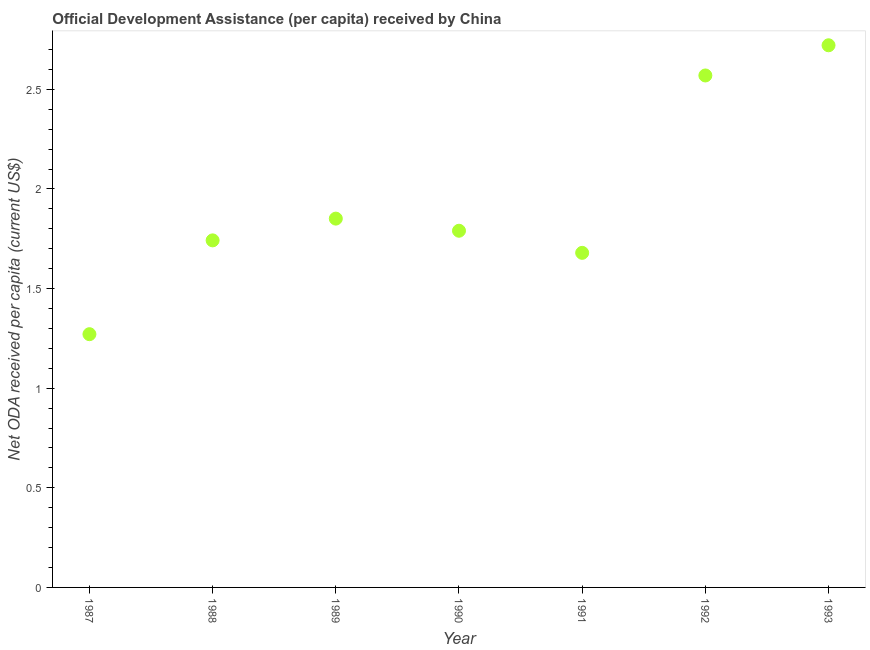What is the net oda received per capita in 1987?
Provide a short and direct response. 1.27. Across all years, what is the maximum net oda received per capita?
Give a very brief answer. 2.72. Across all years, what is the minimum net oda received per capita?
Ensure brevity in your answer.  1.27. In which year was the net oda received per capita minimum?
Ensure brevity in your answer.  1987. What is the sum of the net oda received per capita?
Give a very brief answer. 13.63. What is the difference between the net oda received per capita in 1987 and 1989?
Offer a very short reply. -0.58. What is the average net oda received per capita per year?
Your response must be concise. 1.95. What is the median net oda received per capita?
Offer a terse response. 1.79. In how many years, is the net oda received per capita greater than 1.7 US$?
Offer a very short reply. 5. Do a majority of the years between 1993 and 1988 (inclusive) have net oda received per capita greater than 0.4 US$?
Provide a short and direct response. Yes. What is the ratio of the net oda received per capita in 1989 to that in 1991?
Your answer should be very brief. 1.1. Is the net oda received per capita in 1987 less than that in 1988?
Provide a short and direct response. Yes. What is the difference between the highest and the second highest net oda received per capita?
Give a very brief answer. 0.15. What is the difference between the highest and the lowest net oda received per capita?
Your answer should be very brief. 1.45. How many dotlines are there?
Your response must be concise. 1. What is the difference between two consecutive major ticks on the Y-axis?
Your answer should be very brief. 0.5. Are the values on the major ticks of Y-axis written in scientific E-notation?
Your answer should be compact. No. Does the graph contain grids?
Keep it short and to the point. No. What is the title of the graph?
Provide a short and direct response. Official Development Assistance (per capita) received by China. What is the label or title of the X-axis?
Your answer should be compact. Year. What is the label or title of the Y-axis?
Ensure brevity in your answer.  Net ODA received per capita (current US$). What is the Net ODA received per capita (current US$) in 1987?
Provide a short and direct response. 1.27. What is the Net ODA received per capita (current US$) in 1988?
Ensure brevity in your answer.  1.74. What is the Net ODA received per capita (current US$) in 1989?
Ensure brevity in your answer.  1.85. What is the Net ODA received per capita (current US$) in 1990?
Keep it short and to the point. 1.79. What is the Net ODA received per capita (current US$) in 1991?
Your answer should be compact. 1.68. What is the Net ODA received per capita (current US$) in 1992?
Offer a terse response. 2.57. What is the Net ODA received per capita (current US$) in 1993?
Give a very brief answer. 2.72. What is the difference between the Net ODA received per capita (current US$) in 1987 and 1988?
Your response must be concise. -0.47. What is the difference between the Net ODA received per capita (current US$) in 1987 and 1989?
Your answer should be very brief. -0.58. What is the difference between the Net ODA received per capita (current US$) in 1987 and 1990?
Your answer should be compact. -0.52. What is the difference between the Net ODA received per capita (current US$) in 1987 and 1991?
Provide a short and direct response. -0.41. What is the difference between the Net ODA received per capita (current US$) in 1987 and 1992?
Offer a very short reply. -1.3. What is the difference between the Net ODA received per capita (current US$) in 1987 and 1993?
Offer a very short reply. -1.45. What is the difference between the Net ODA received per capita (current US$) in 1988 and 1989?
Give a very brief answer. -0.11. What is the difference between the Net ODA received per capita (current US$) in 1988 and 1990?
Make the answer very short. -0.05. What is the difference between the Net ODA received per capita (current US$) in 1988 and 1991?
Your response must be concise. 0.06. What is the difference between the Net ODA received per capita (current US$) in 1988 and 1992?
Ensure brevity in your answer.  -0.83. What is the difference between the Net ODA received per capita (current US$) in 1988 and 1993?
Keep it short and to the point. -0.98. What is the difference between the Net ODA received per capita (current US$) in 1989 and 1990?
Your answer should be very brief. 0.06. What is the difference between the Net ODA received per capita (current US$) in 1989 and 1991?
Keep it short and to the point. 0.17. What is the difference between the Net ODA received per capita (current US$) in 1989 and 1992?
Make the answer very short. -0.72. What is the difference between the Net ODA received per capita (current US$) in 1989 and 1993?
Your answer should be compact. -0.87. What is the difference between the Net ODA received per capita (current US$) in 1990 and 1991?
Your answer should be very brief. 0.11. What is the difference between the Net ODA received per capita (current US$) in 1990 and 1992?
Ensure brevity in your answer.  -0.78. What is the difference between the Net ODA received per capita (current US$) in 1990 and 1993?
Offer a very short reply. -0.93. What is the difference between the Net ODA received per capita (current US$) in 1991 and 1992?
Give a very brief answer. -0.89. What is the difference between the Net ODA received per capita (current US$) in 1991 and 1993?
Give a very brief answer. -1.04. What is the difference between the Net ODA received per capita (current US$) in 1992 and 1993?
Offer a terse response. -0.15. What is the ratio of the Net ODA received per capita (current US$) in 1987 to that in 1988?
Provide a succinct answer. 0.73. What is the ratio of the Net ODA received per capita (current US$) in 1987 to that in 1989?
Give a very brief answer. 0.69. What is the ratio of the Net ODA received per capita (current US$) in 1987 to that in 1990?
Keep it short and to the point. 0.71. What is the ratio of the Net ODA received per capita (current US$) in 1987 to that in 1991?
Provide a succinct answer. 0.76. What is the ratio of the Net ODA received per capita (current US$) in 1987 to that in 1992?
Make the answer very short. 0.49. What is the ratio of the Net ODA received per capita (current US$) in 1987 to that in 1993?
Provide a succinct answer. 0.47. What is the ratio of the Net ODA received per capita (current US$) in 1988 to that in 1989?
Your answer should be compact. 0.94. What is the ratio of the Net ODA received per capita (current US$) in 1988 to that in 1990?
Provide a short and direct response. 0.97. What is the ratio of the Net ODA received per capita (current US$) in 1988 to that in 1991?
Your response must be concise. 1.04. What is the ratio of the Net ODA received per capita (current US$) in 1988 to that in 1992?
Offer a terse response. 0.68. What is the ratio of the Net ODA received per capita (current US$) in 1988 to that in 1993?
Provide a short and direct response. 0.64. What is the ratio of the Net ODA received per capita (current US$) in 1989 to that in 1990?
Provide a succinct answer. 1.03. What is the ratio of the Net ODA received per capita (current US$) in 1989 to that in 1991?
Offer a terse response. 1.1. What is the ratio of the Net ODA received per capita (current US$) in 1989 to that in 1992?
Provide a short and direct response. 0.72. What is the ratio of the Net ODA received per capita (current US$) in 1989 to that in 1993?
Provide a short and direct response. 0.68. What is the ratio of the Net ODA received per capita (current US$) in 1990 to that in 1991?
Your answer should be very brief. 1.07. What is the ratio of the Net ODA received per capita (current US$) in 1990 to that in 1992?
Provide a short and direct response. 0.7. What is the ratio of the Net ODA received per capita (current US$) in 1990 to that in 1993?
Ensure brevity in your answer.  0.66. What is the ratio of the Net ODA received per capita (current US$) in 1991 to that in 1992?
Provide a succinct answer. 0.65. What is the ratio of the Net ODA received per capita (current US$) in 1991 to that in 1993?
Ensure brevity in your answer.  0.62. What is the ratio of the Net ODA received per capita (current US$) in 1992 to that in 1993?
Provide a succinct answer. 0.94. 